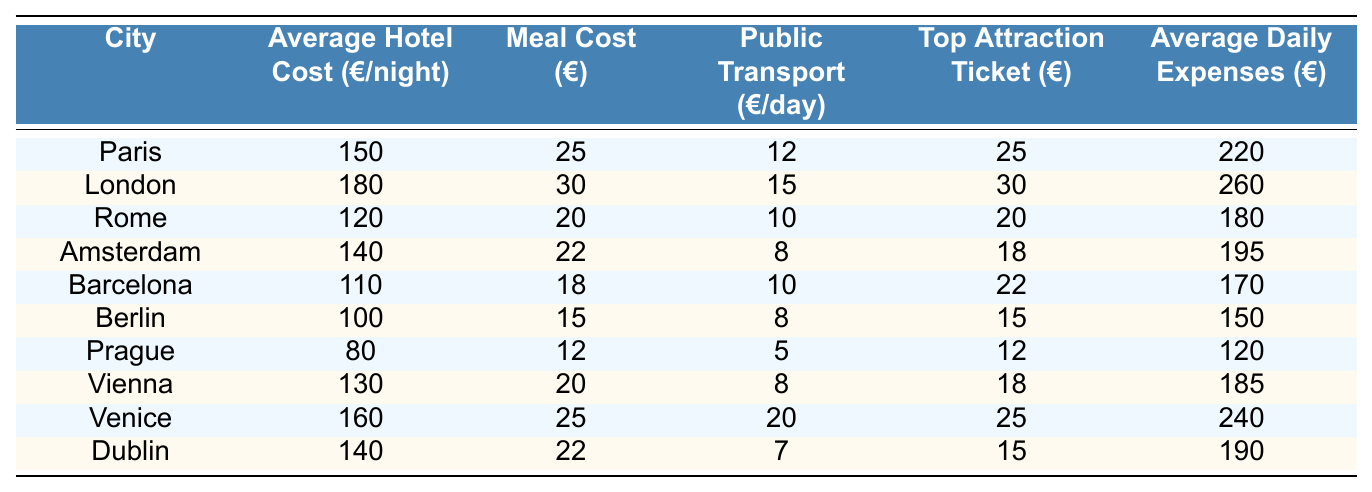What is the average hotel cost per night in Rome? The table lists the average hotel cost in Rome as €120.
Answer: 120 Which city has the highest average daily expenses? According to the table, London has the highest average daily expenses at €260.
Answer: London What is the total cost of a day in Berlin (average hotel, meal, public transport, attraction)? In Berlin, the average hotel cost is €100, meal cost is €15, public transport is €8, and top attraction ticket is €15. Total = 100 + 15 + 8 + 15 = €138.
Answer: 138 Which city has a lower average daily expense, Barcelona or Prague? Barcelona has average daily expenses of €170, while Prague has €120. Since €120 < €170, Prague has lower expenses.
Answer: Prague How much more expensive is a meal in London compared to Rome? The meal cost in London is €30, and in Rome, it is €20. The difference is 30 - 20 = €10.
Answer: €10 What is the average daily expense for the city with the lowest hotel cost? Prague has the lowest hotel cost at €80, and its average daily expenses are €120.
Answer: 120 Which two cities have the same meal cost? Dublin and Amsterdam both have a meal cost of €22.
Answer: Dublin and Amsterdam If I visit all top attractions in Vienna and Amsterdam, how much would I spend on tickets? The top attraction ticket in Vienna is €18 and in Amsterdam is €18. Total = 18 + 18 = €36.
Answer: €36 Is the average daily expense in Venice higher than in Berlin? Venice has an average daily expense of €240, while Berlin has €150. Since €240 > €150, it's true that Venice is higher.
Answer: Yes Which city is cheaper overall for travelers: Rome or Barcelona? Rome has an average daily expense of €180, while Barcelona has €170. Since €170 < €180, Barcelona is cheaper for travelers.
Answer: Barcelona 